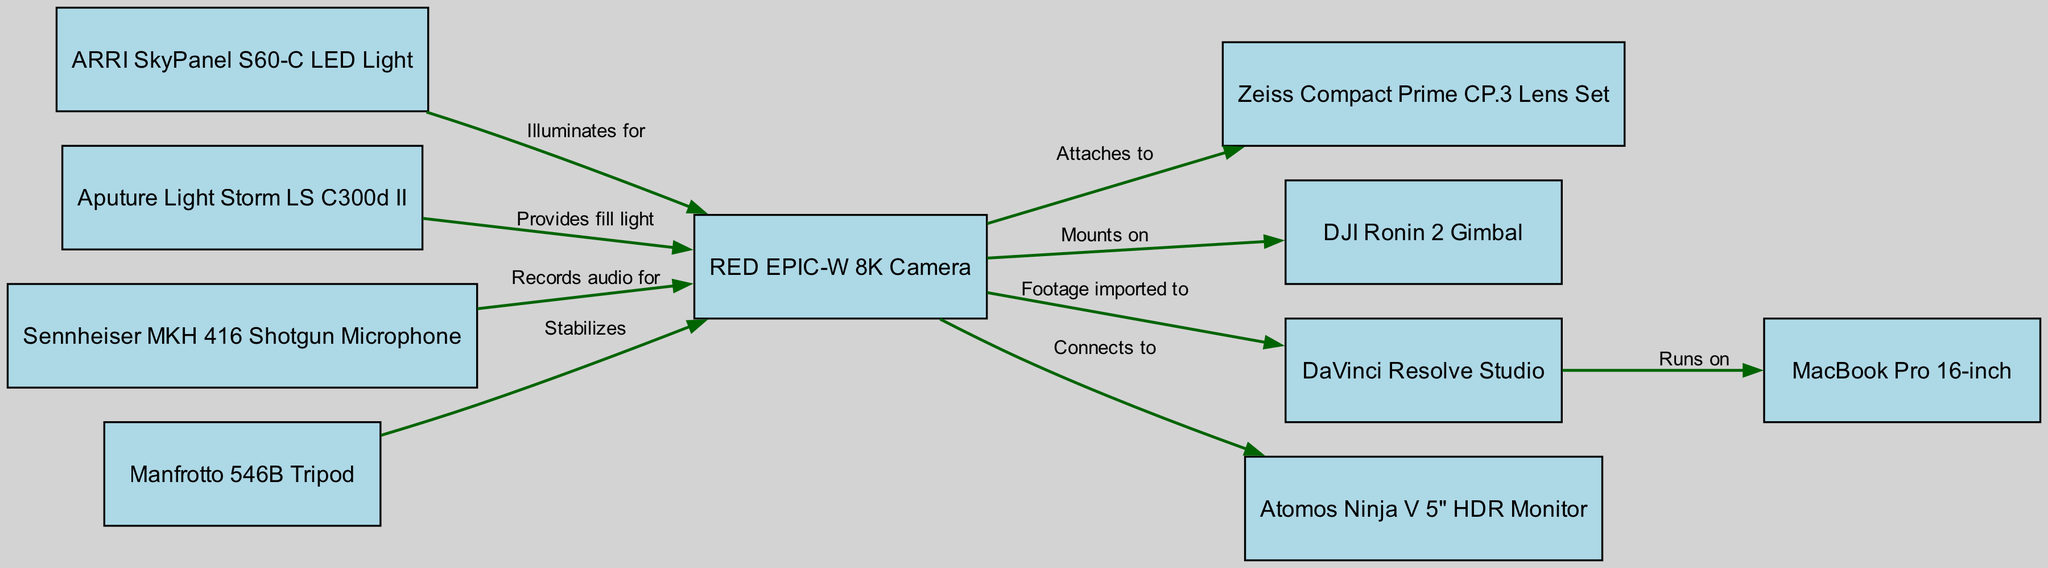What is the total number of nodes in the diagram? The diagram lists a total of ten nodes related to technical equipment, including cameras, lenses, lights, and other filmmaking tools.
Answer: 10 Which light source provides fill light for the RED EPIC-W 8K Camera? The diagram indicates that the Aputure Light Storm LS C300d II is connected to the RED EPIC-W 8K Camera with the label “Provides fill light,” making it the source of fill light.
Answer: Aputure Light Storm LS C300d II How many edges originate from the RED EPIC-W 8K Camera? By examining the connections in the diagram, the RED EPIC-W 8K Camera has five outgoing edges leading to different pieces of equipment.
Answer: 5 Which equipment records audio for the RED EPIC-W 8K Camera? The diagram shows that the Sennheiser MKH 416 Shotgun Microphone is directly connected to the RED EPIC-W 8K Camera with the label “Records audio for,” identifying it as the audio recording device.
Answer: Sennheiser MKH 416 Shotgun Microphone What is the relationship between the Manfrotto 546B Tripod and the RED EPIC-W 8K Camera? The diagram states that the Manfrotto 546B Tripod stabilizes the RED EPIC-W 8K Camera, indicating the function of the tripod in relation to the camera setup.
Answer: Stabilizes Which software runs on the MacBook Pro 16-inch? According to the diagram, the connection from DaVinci Resolve Studio to the MacBook Pro 16-inch indicates that it is the software that runs on the laptop.
Answer: DaVinci Resolve Studio How does the RED EPIC-W 8K Camera benefit from the ARRI SkyPanel S60-C LED Light? The diagram reveals that the ARRI SkyPanel S60-C LED Light illuminates the RED EPIC-W 8K Camera, showing its role in enhancing lighting conditions during filming.
Answer: Illuminates for Which equipment connects to the Atomos Ninja V 5" HDR Monitor? The diagram specifies that the RED EPIC-W 8K Camera connects to the Atomos Ninja V 5" HDR Monitor, indicating that this camera output feeds into the monitor.
Answer: RED EPIC-W 8K Camera What is a unique feature of directed graphs illustrated by this diagram? Directed graphs contain edges that have a specific direction, indicating a one-way relationship between connected nodes, as shown by the arrows illustrating equipment dependencies and functionalities.
Answer: Directional relationships 